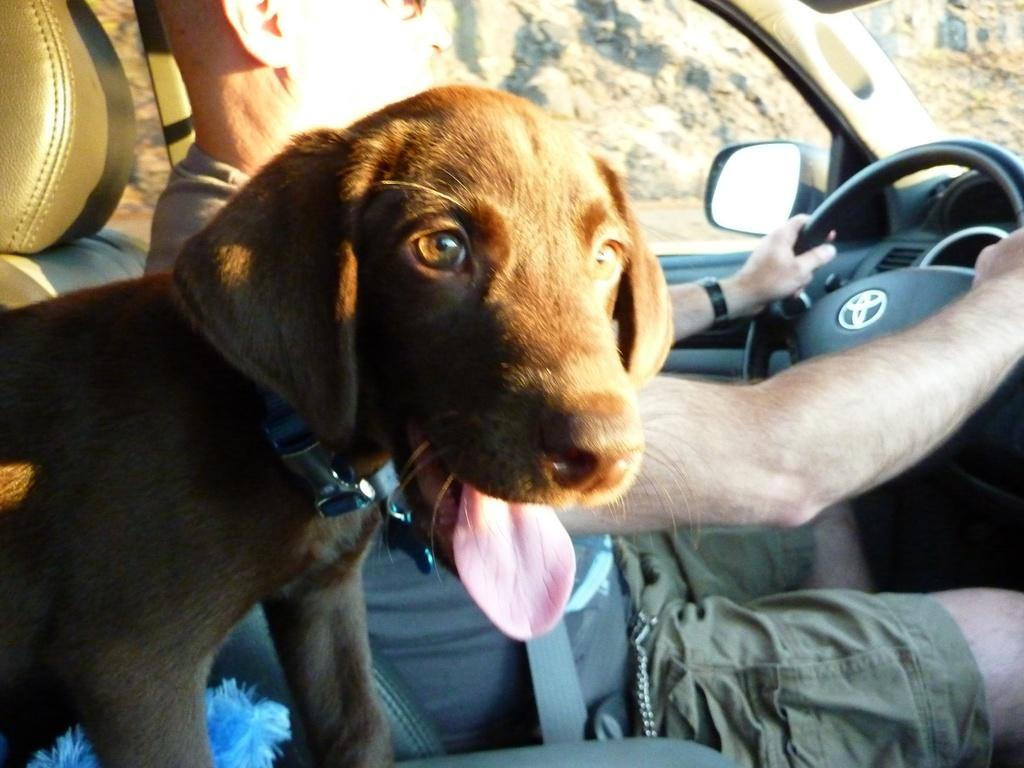What is the man doing in the image? The man is sitting on a vehicle in the image. What other living creature is present on the vehicle? There is a dog on the vehicle in the image. Where is the vehicle located in the image? The vehicle is in the middle of the image. Where is the dog positioned on the vehicle? The dog is on the bottom left side of the image. What can be seen through a window in the image? There is a hill visible through a window in the image. What type of bubble is the man blowing in the image? There is no bubble present in the image. What kind of bun is the dog eating in the image? There is no bun present in the image. 